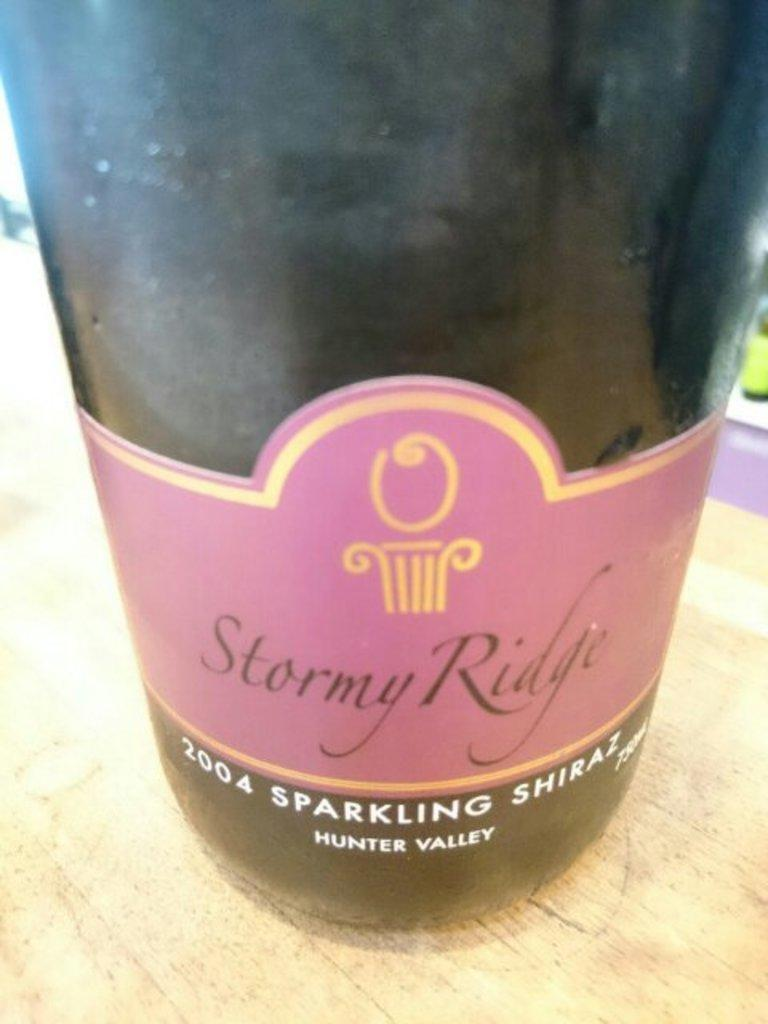<image>
Render a clear and concise summary of the photo. A bottle of stormy ridge is sitting on the table. 